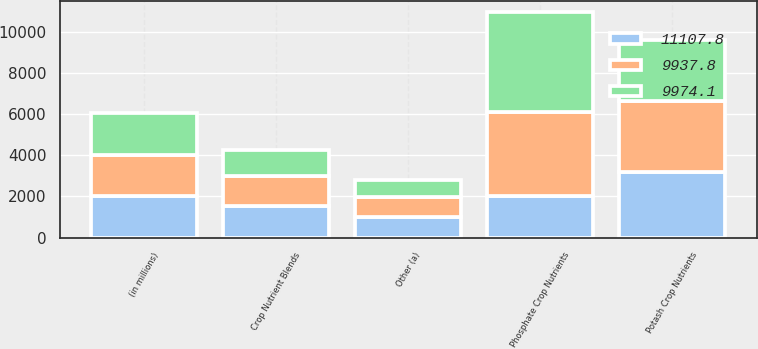<chart> <loc_0><loc_0><loc_500><loc_500><stacked_bar_chart><ecel><fcel>(in millions)<fcel>Phosphate Crop Nutrients<fcel>Potash Crop Nutrients<fcel>Crop Nutrient Blends<fcel>Other (a)<nl><fcel>9937.8<fcel>2013<fcel>4106.1<fcel>3434.5<fcel>1472.3<fcel>961.2<nl><fcel>11107.8<fcel>2012<fcel>2011.5<fcel>3174.4<fcel>1517.1<fcel>997.9<nl><fcel>9974.1<fcel>2011<fcel>4822.4<fcel>3002.8<fcel>1252.5<fcel>860.1<nl></chart> 